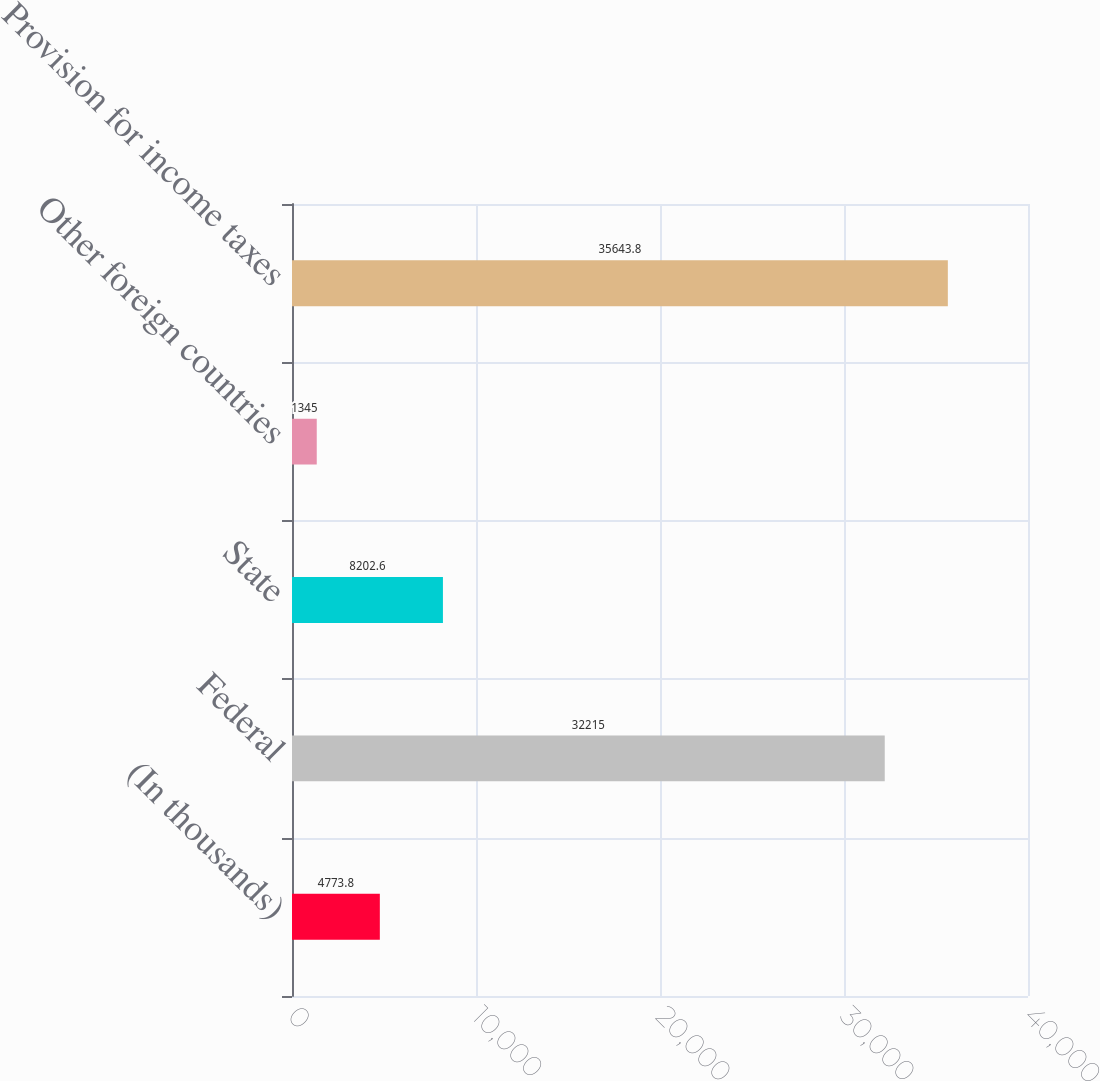<chart> <loc_0><loc_0><loc_500><loc_500><bar_chart><fcel>(In thousands)<fcel>Federal<fcel>State<fcel>Other foreign countries<fcel>Provision for income taxes<nl><fcel>4773.8<fcel>32215<fcel>8202.6<fcel>1345<fcel>35643.8<nl></chart> 